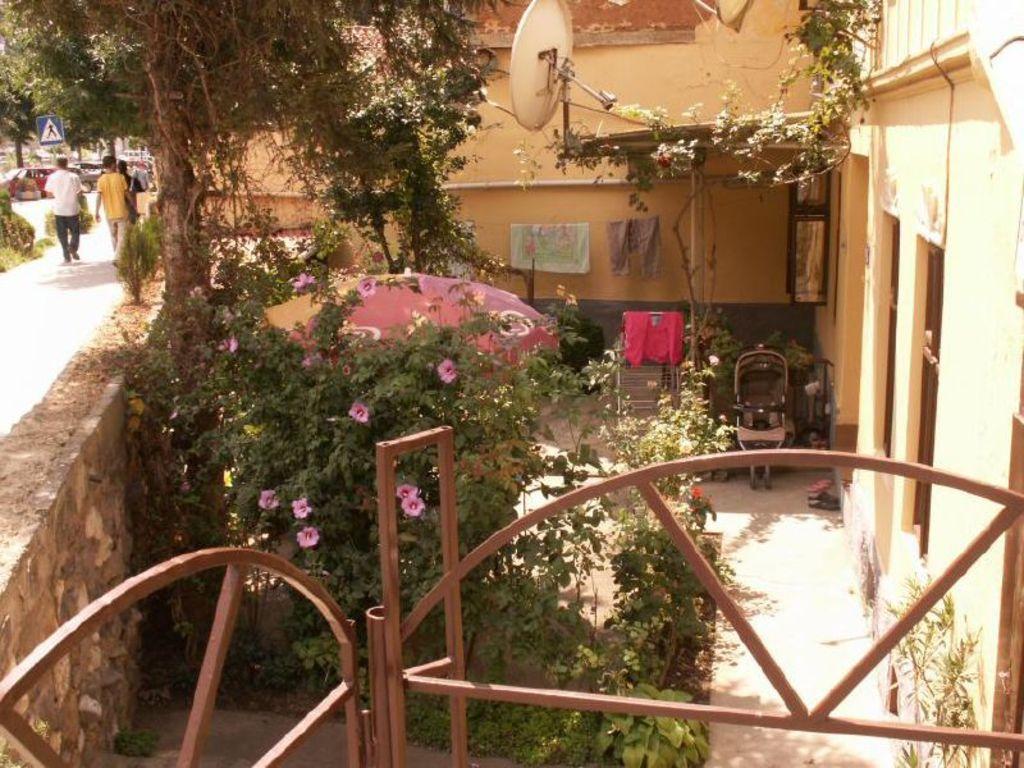How would you summarize this image in a sentence or two? In this image on the left, there is a man, he wears a t shirt, trouser, he is walking and there is a man, he wears a shirt, trouser, he is walking and there are some people, cars, sign boards, trees. In the middle there are trees, dishcloths, doors, house, vehicle, gate, plants, flowers, wall. 